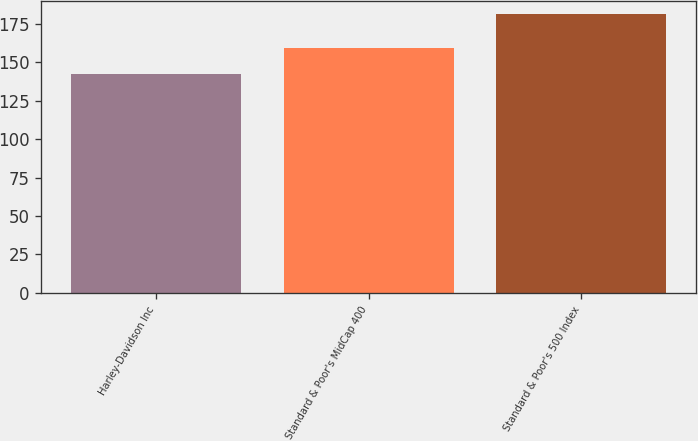Convert chart to OTSL. <chart><loc_0><loc_0><loc_500><loc_500><bar_chart><fcel>Harley-Davidson Inc<fcel>Standard & Poor's MidCap 400<fcel>Standard & Poor's 500 Index<nl><fcel>142<fcel>159<fcel>181<nl></chart> 